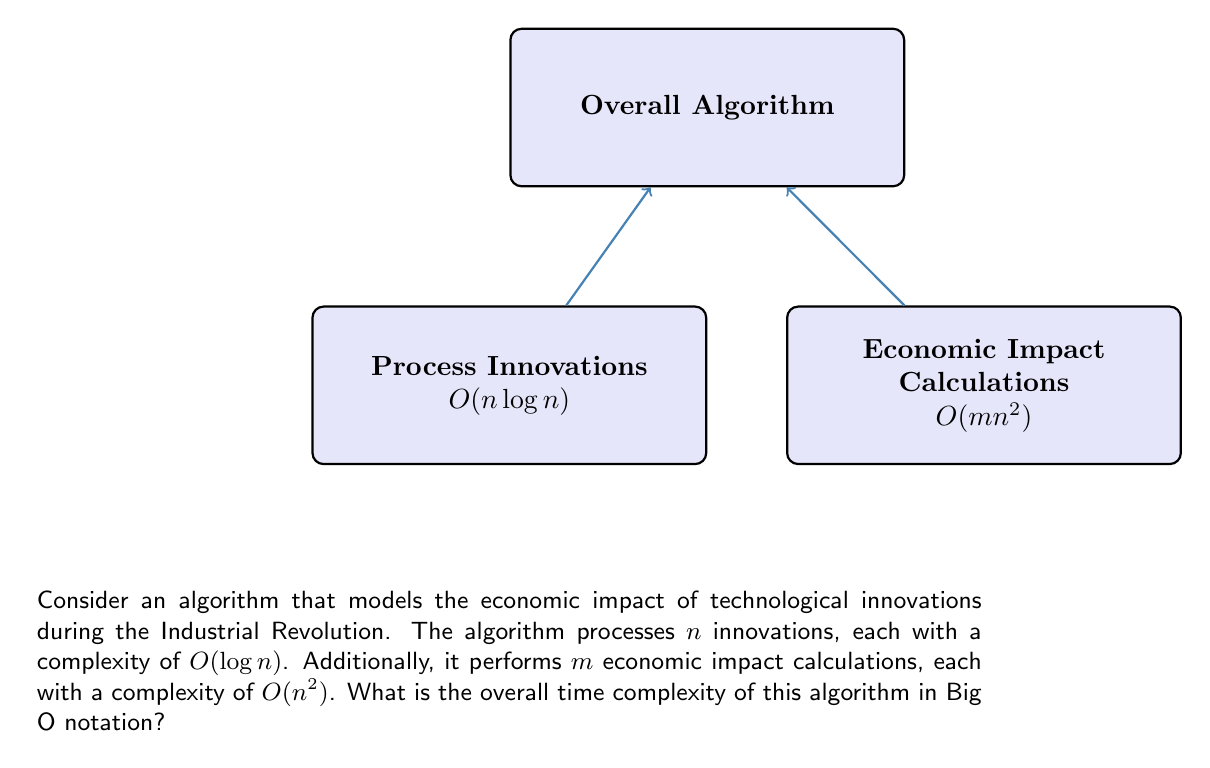Solve this math problem. To determine the overall time complexity, we need to analyze the two main components of the algorithm:

1. Processing innovations:
   - There are $n$ innovations, each processed in $O(\log n)$ time.
   - Total complexity for this part: $O(n \log n)$

2. Economic impact calculations:
   - There are $m$ calculations, each with complexity $O(n^2)$.
   - Total complexity for this part: $O(mn^2)$

The overall time complexity is the sum of these two components:

$$O(n \log n + mn^2)$$

To simplify this expression, we need to consider the dominant term:

- If $m$ is constant or grows slower than $n$, then $O(n^2)$ dominates $O(n \log n)$.
- If $m$ grows faster than or equal to $n$, then $O(mn^2)$ is the dominant term.

Since $m$ is not specified in relation to $n$, we keep both terms to maintain accuracy:

$$O(n \log n + mn^2)$$

This expression represents the upper bound of the algorithm's running time, accounting for both the innovation processing and economic impact calculation components.
Answer: $O(n \log n + mn^2)$ 